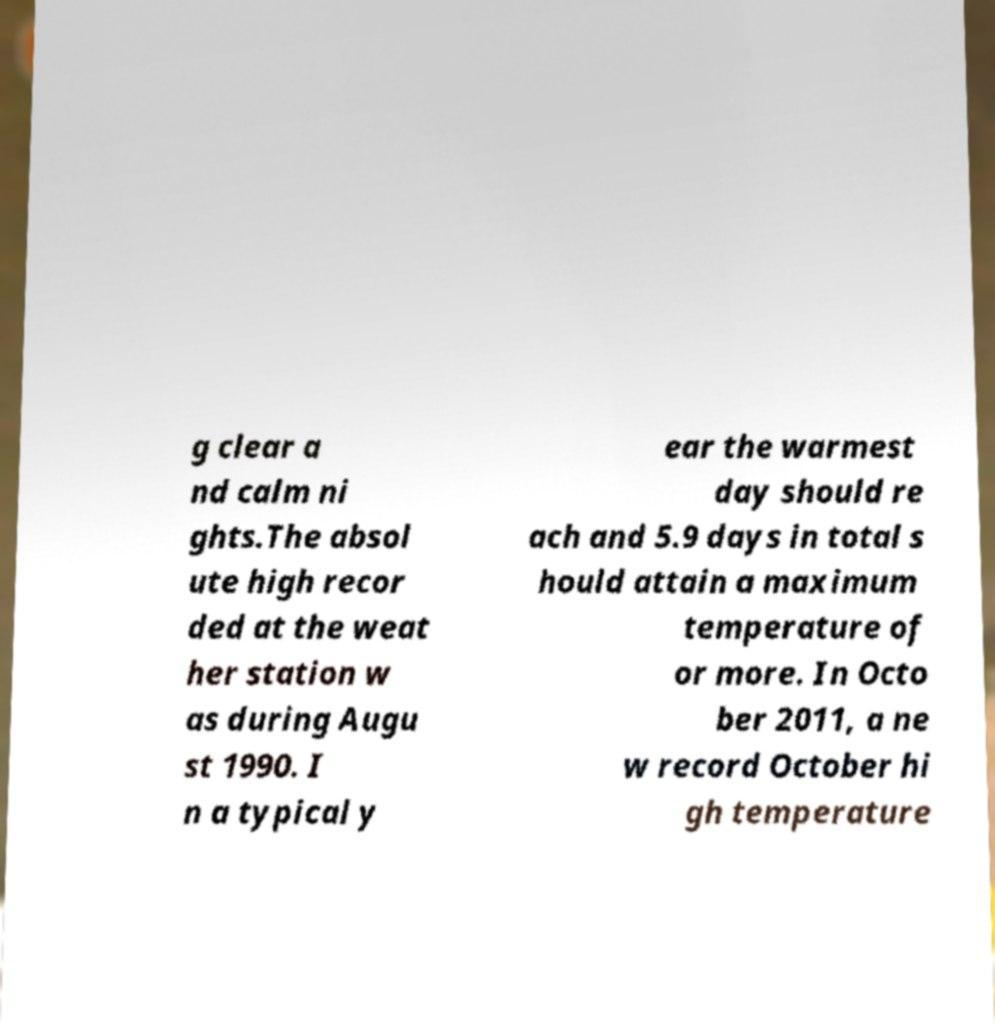Could you assist in decoding the text presented in this image and type it out clearly? g clear a nd calm ni ghts.The absol ute high recor ded at the weat her station w as during Augu st 1990. I n a typical y ear the warmest day should re ach and 5.9 days in total s hould attain a maximum temperature of or more. In Octo ber 2011, a ne w record October hi gh temperature 